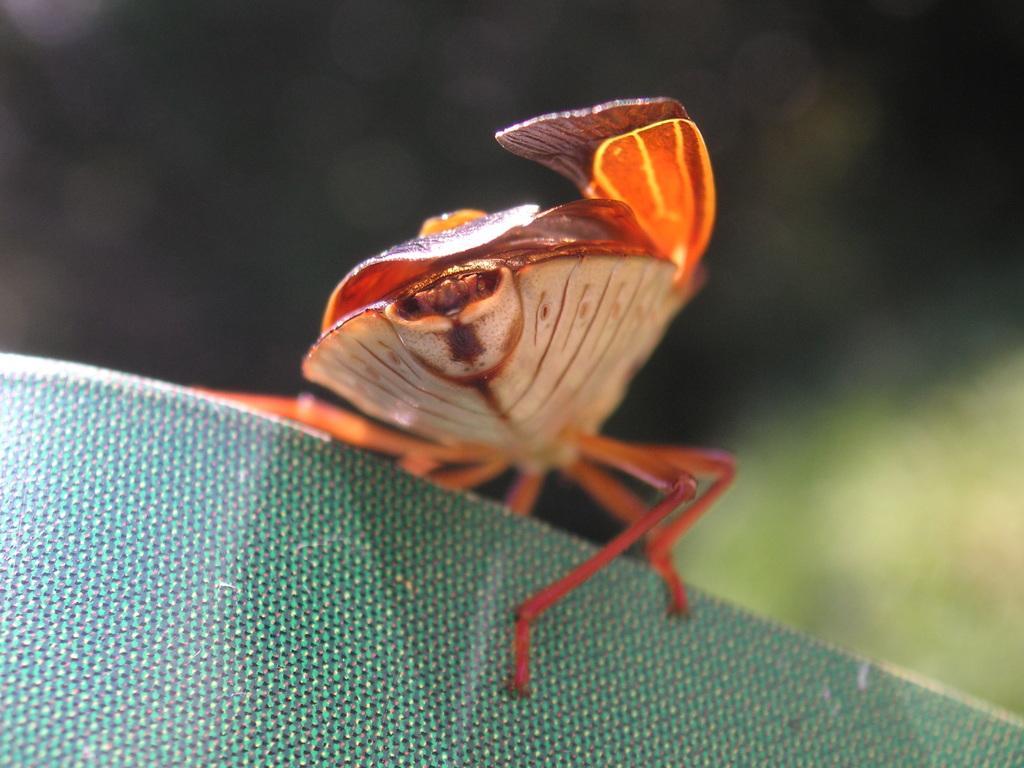Please provide a concise description of this image. Background portion of the picture is completely blur. In this picture we can see an insect on a green surface. 